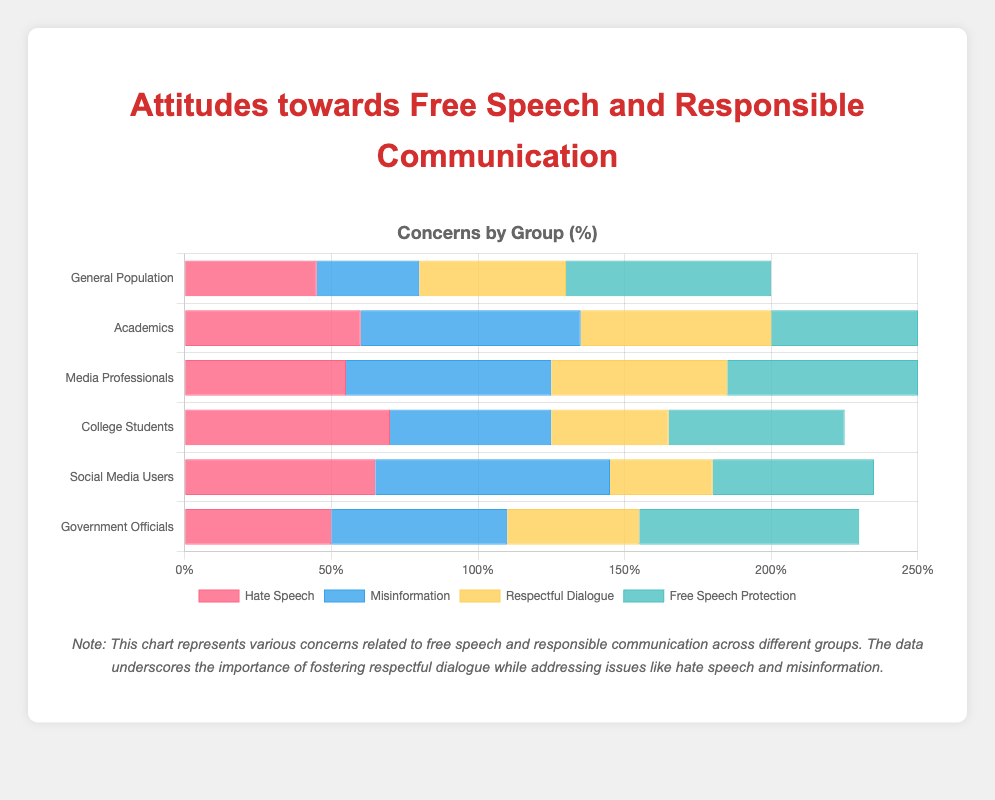What percentage of College Students are concerned about Hate Speech? Identify the value directly from the "College Students" category under the "Hate Speech" label.
Answer: 70% Which group is most concerned about Misinformation? Compare the data values across all categories for the "Misinformation" label and determine which group has the highest percentage.
Answer: Social Media Users What is the difference in concern for Respectful Dialogue between General Population and College Students? Subtract the percentage of College Students concerned about Respectful Dialogue from that of the General Population. Specifically, 50 (General Population) - 40 (College Students).
Answer: 10% Which category shows the highest concern for Free Speech Protection, and what is this percentage? Compare the values in the "Free Speech Protection" row to find the highest one.
Answer: Government Officials, 75% What is the average concern for Misinformation among General Population, Academics, and Media Professionals? Add the percentages for Misinformation in these three categories and divide by 3. Specifically: (35 + 75 + 70)/3.
Answer: 60% Which group shows an equal percentage of concern for Hate Speech and Respectful Dialogue, and what is this percentage? Compare the values for each group to see where the percentages for Hate Speech and Respectful Dialogue are equal.
Answer: Government Officials, 50% Rank the categories from the highest to the lowest concern for Hate Speech. List the categories in descending order based on their respective values for Hate Speech.
Answer: College Students, Social Media Users, Academics, Media Professionals, Government Officials, General Population Which concern shows the least variation across all groups? Calculate the range (maximum value minus minimum value) for each concern and identify the one with the smallest range.
Answer: Respectful Dialogue What is the combined percentage of Media Professionals concerned about both Hate Speech and Misinformation? Add the percentages for Hate Speech and Misinformation in the Media Professionals category. Specifically: 55 (Hate Speech) + 70 (Misinformation).
Answer: 125% Is the concern for Misinformation greater in Academics than in Government Officials, and by how much? Subtract the percentage of Government Officials concerned about Misinformation from that of Academics. Specifically: 75 (Academics) - 60 (Government Officials).
Answer: Yes, by 15% 